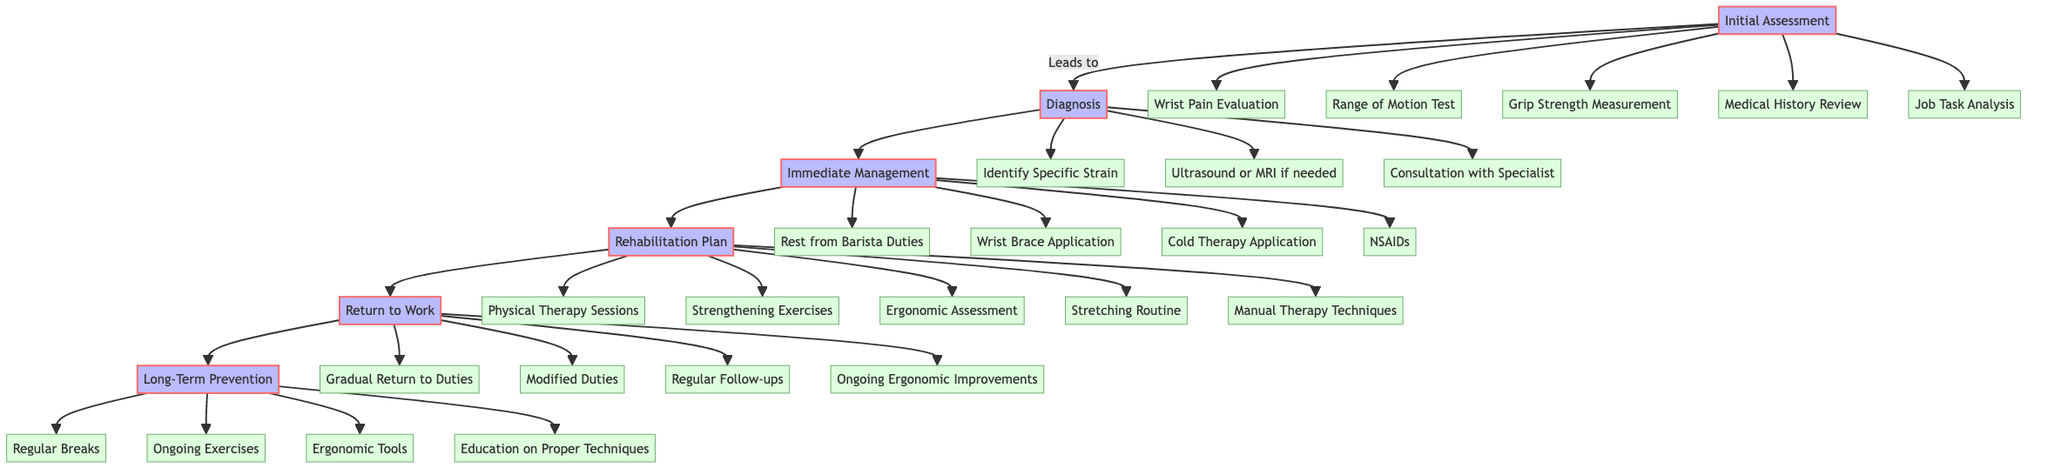What is the first step in the pathway? The first step in the pathway is labeled "Initial Assessment," which is the starting point of the management and rehabilitation process for wrist strain.
Answer: Initial Assessment How many elements are in the Immediate Management step? In the Immediate Management step, there are four elements: Rest from Barista Duties, Wrist Brace Application, Cold Therapy Application, and Nonsteroidal Anti-inflammatory Drugs (NSAIDs).
Answer: 4 What follows the Diagnosis step in the pathway? The step that follows the Diagnosis step is "Immediate Management," which indicates the next phase after diagnosing the wrist strain.
Answer: Immediate Management Which component is included in the Long-Term Prevention section? The Long-Term Prevention section includes components like Regular Breaks during Shifts, Ongoing Strength and Flexibility Exercises, Ergonomic Tools, and Education on Proper Techniques. One specific component is "Regular Breaks during Shifts."
Answer: Regular Breaks during Shifts What is the relationship between the Rehabilitation Plan and Return to Work? The relationship is sequential; the "Rehabilitation Plan" feeds directly into the "Return to Work," showing the progression from rehabilitation to returning to barista duties.
Answer: Progressive relationship Which evaluation is part of the Initial Assessment? In the Initial Assessment, one component is "Wrist Pain Evaluation," which is essential for identifying issues related to wrist strain.
Answer: Wrist Pain Evaluation What must be done before starting rehabilitation? Before starting rehabilitation, "Immediate Management" must be completed, which includes rest and other treatments to address the strain.
Answer: Immediate Management How many major steps are in the pathway? There are six major steps in the pathway: Initial Assessment, Diagnosis, Immediate Management, Rehabilitation Plan, Return to Work, and Long-Term Prevention.
Answer: 6 